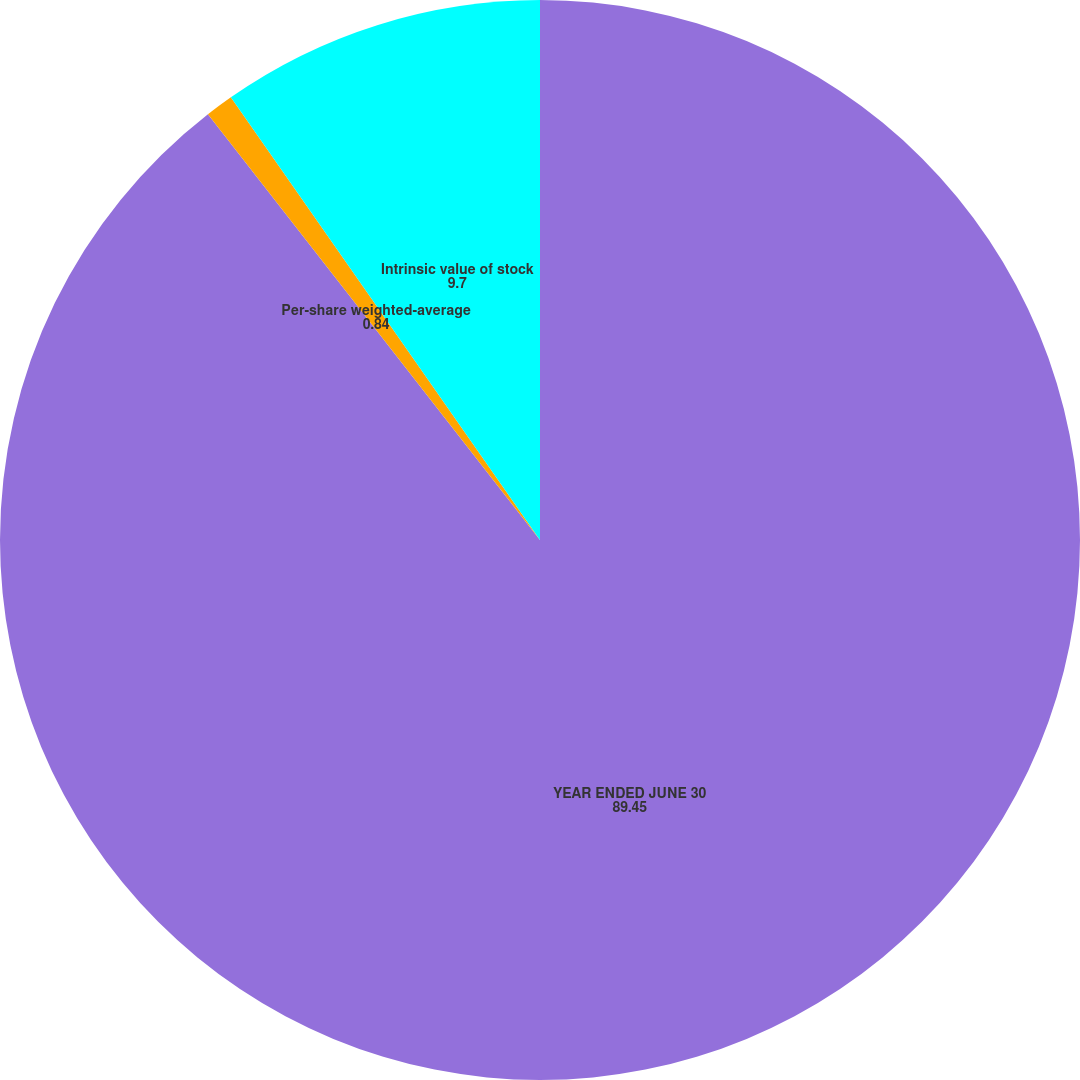Convert chart. <chart><loc_0><loc_0><loc_500><loc_500><pie_chart><fcel>YEAR ENDED JUNE 30<fcel>Per-share weighted-average<fcel>Intrinsic value of stock<nl><fcel>89.45%<fcel>0.84%<fcel>9.7%<nl></chart> 